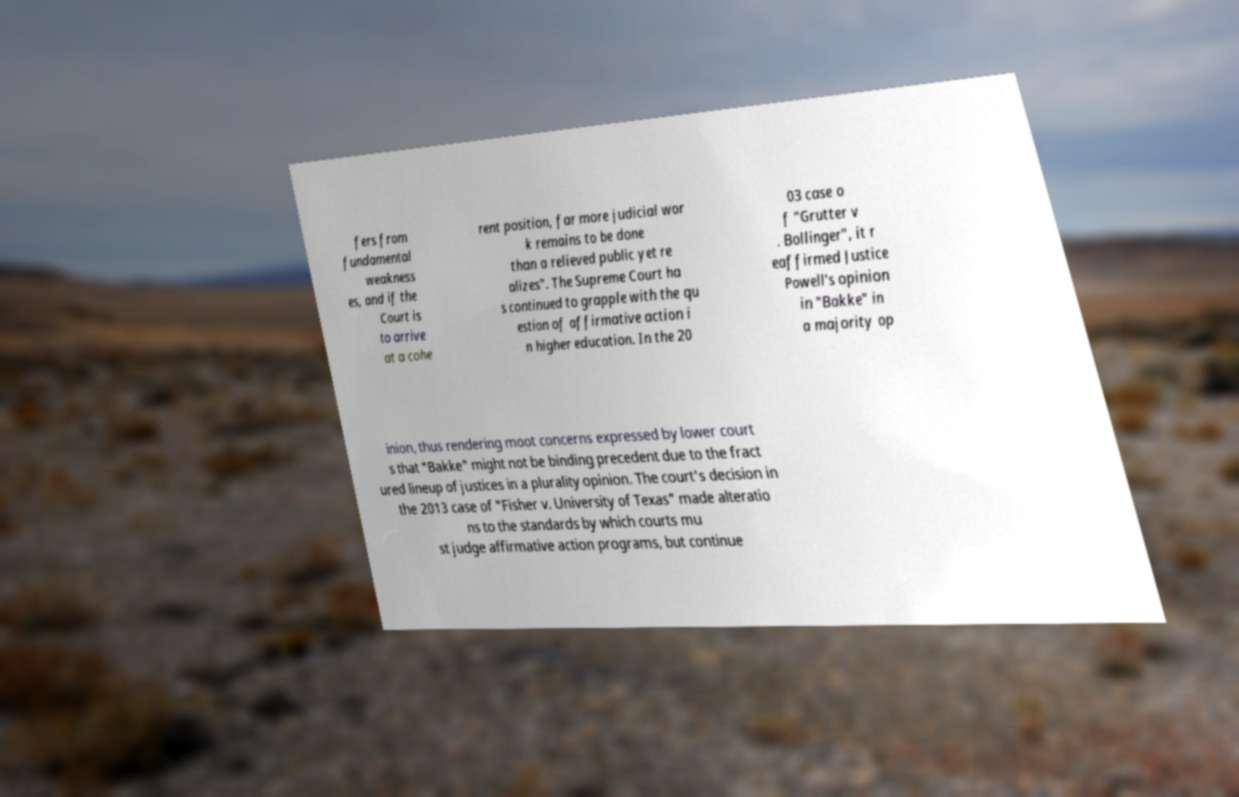For documentation purposes, I need the text within this image transcribed. Could you provide that? fers from fundamental weakness es, and if the Court is to arrive at a cohe rent position, far more judicial wor k remains to be done than a relieved public yet re alizes". The Supreme Court ha s continued to grapple with the qu estion of affirmative action i n higher education. In the 20 03 case o f "Grutter v . Bollinger", it r eaffirmed Justice Powell's opinion in "Bakke" in a majority op inion, thus rendering moot concerns expressed by lower court s that "Bakke" might not be binding precedent due to the fract ured lineup of justices in a plurality opinion. The court's decision in the 2013 case of "Fisher v. University of Texas" made alteratio ns to the standards by which courts mu st judge affirmative action programs, but continue 